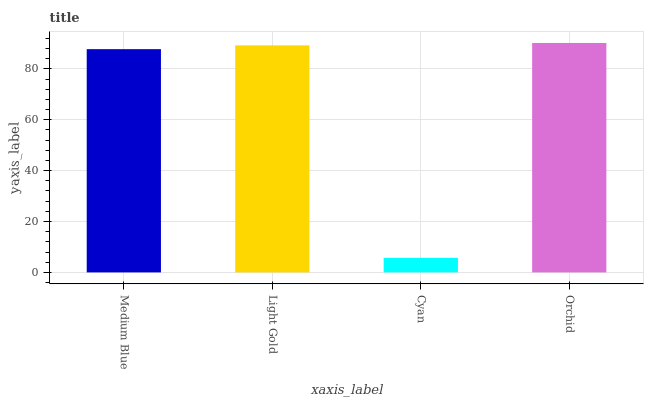Is Cyan the minimum?
Answer yes or no. Yes. Is Orchid the maximum?
Answer yes or no. Yes. Is Light Gold the minimum?
Answer yes or no. No. Is Light Gold the maximum?
Answer yes or no. No. Is Light Gold greater than Medium Blue?
Answer yes or no. Yes. Is Medium Blue less than Light Gold?
Answer yes or no. Yes. Is Medium Blue greater than Light Gold?
Answer yes or no. No. Is Light Gold less than Medium Blue?
Answer yes or no. No. Is Light Gold the high median?
Answer yes or no. Yes. Is Medium Blue the low median?
Answer yes or no. Yes. Is Medium Blue the high median?
Answer yes or no. No. Is Light Gold the low median?
Answer yes or no. No. 